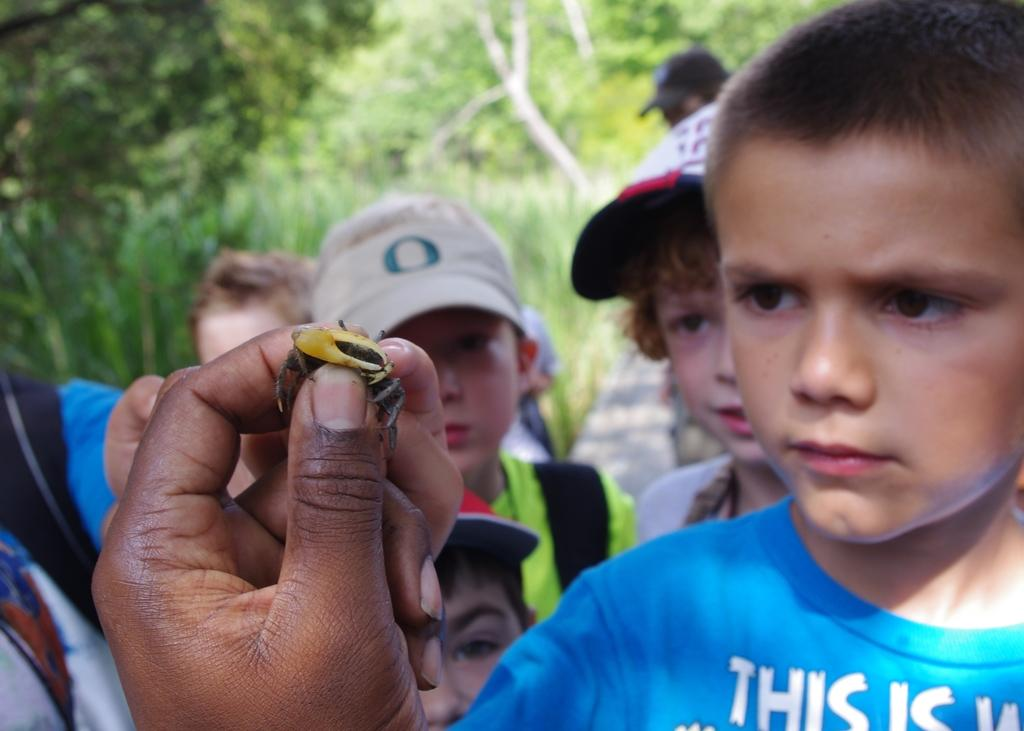What is the person in the image holding? The person's hand is holding an insect in the image. How many people are present in the image? There is a group of people in the image. What can be seen in the background of the image? Trees are visible in the background of the image. What type of birds can be seen flying near the border in the image? There are no birds or borders present in the image; it features a person holding an insect and a group of people with trees in the background. 